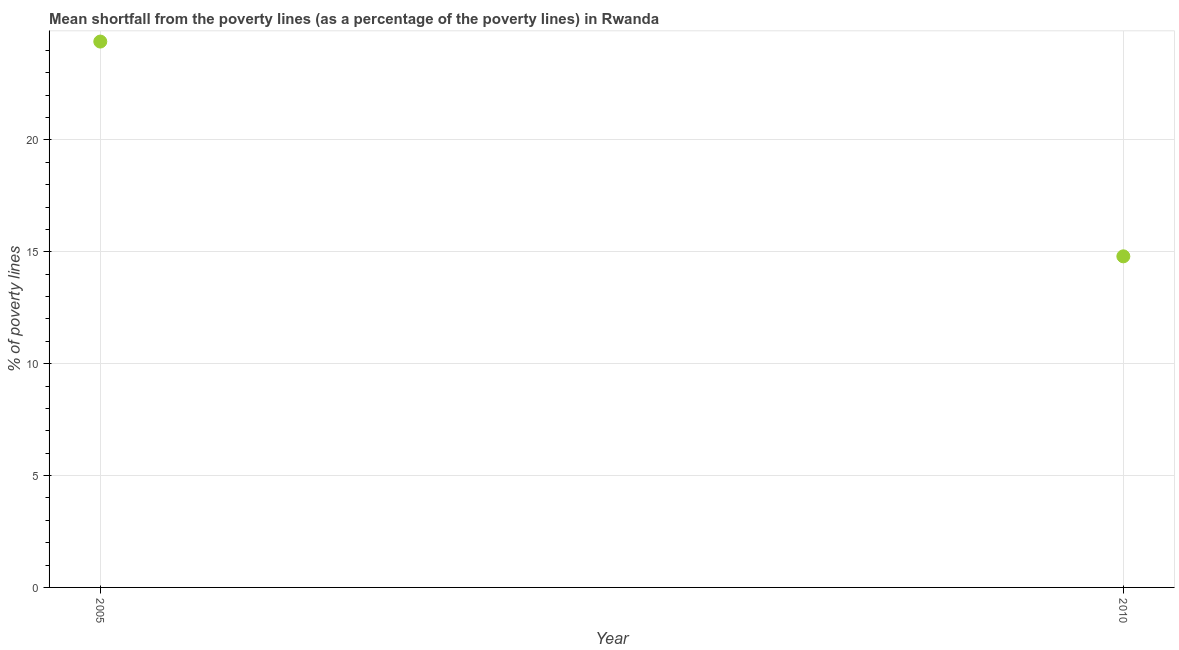What is the poverty gap at national poverty lines in 2005?
Your answer should be very brief. 24.4. Across all years, what is the maximum poverty gap at national poverty lines?
Provide a succinct answer. 24.4. Across all years, what is the minimum poverty gap at national poverty lines?
Give a very brief answer. 14.8. In which year was the poverty gap at national poverty lines minimum?
Make the answer very short. 2010. What is the sum of the poverty gap at national poverty lines?
Your answer should be very brief. 39.2. What is the difference between the poverty gap at national poverty lines in 2005 and 2010?
Offer a terse response. 9.6. What is the average poverty gap at national poverty lines per year?
Your response must be concise. 19.6. What is the median poverty gap at national poverty lines?
Give a very brief answer. 19.6. Do a majority of the years between 2005 and 2010 (inclusive) have poverty gap at national poverty lines greater than 23 %?
Your answer should be very brief. No. What is the ratio of the poverty gap at national poverty lines in 2005 to that in 2010?
Offer a very short reply. 1.65. How many dotlines are there?
Your answer should be very brief. 1. What is the difference between two consecutive major ticks on the Y-axis?
Ensure brevity in your answer.  5. What is the title of the graph?
Your answer should be very brief. Mean shortfall from the poverty lines (as a percentage of the poverty lines) in Rwanda. What is the label or title of the Y-axis?
Provide a succinct answer. % of poverty lines. What is the % of poverty lines in 2005?
Offer a terse response. 24.4. What is the ratio of the % of poverty lines in 2005 to that in 2010?
Keep it short and to the point. 1.65. 